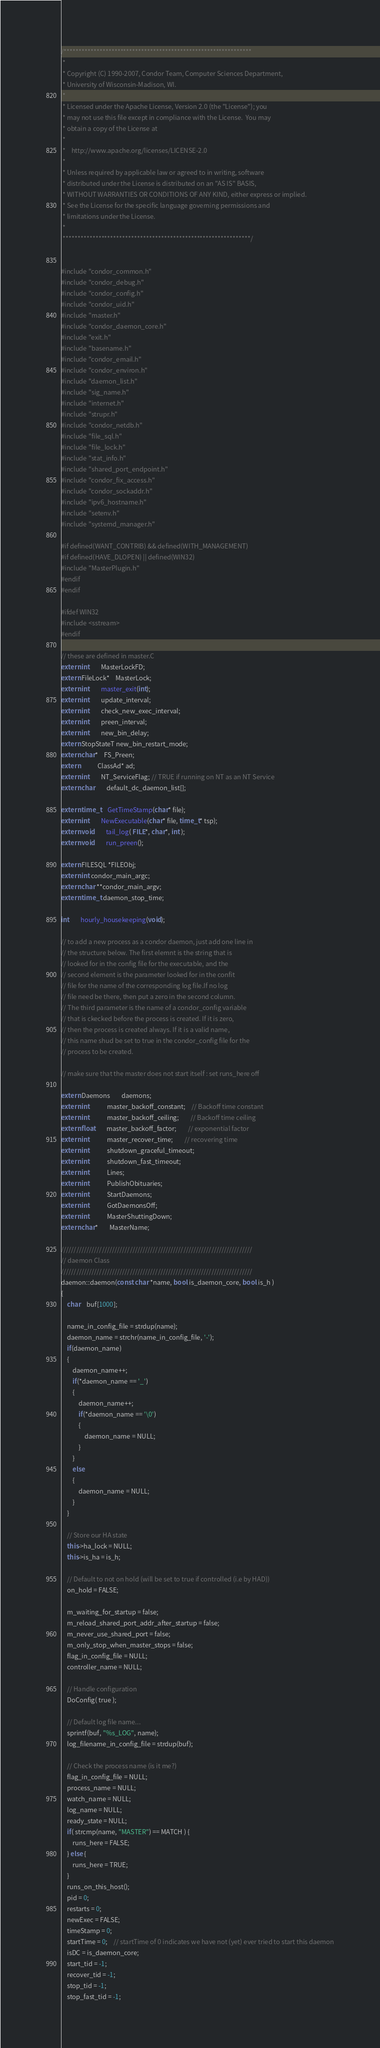<code> <loc_0><loc_0><loc_500><loc_500><_C++_>/***************************************************************
 *
 * Copyright (C) 1990-2007, Condor Team, Computer Sciences Department,
 * University of Wisconsin-Madison, WI.
 * 
 * Licensed under the Apache License, Version 2.0 (the "License"); you
 * may not use this file except in compliance with the License.  You may
 * obtain a copy of the License at
 * 
 *    http://www.apache.org/licenses/LICENSE-2.0
 * 
 * Unless required by applicable law or agreed to in writing, software
 * distributed under the License is distributed on an "AS IS" BASIS,
 * WITHOUT WARRANTIES OR CONDITIONS OF ANY KIND, either express or implied.
 * See the License for the specific language governing permissions and
 * limitations under the License.
 *
 ***************************************************************/


#include "condor_common.h"
#include "condor_debug.h"
#include "condor_config.h"
#include "condor_uid.h"
#include "master.h"
#include "condor_daemon_core.h"
#include "exit.h"
#include "basename.h"
#include "condor_email.h"
#include "condor_environ.h"
#include "daemon_list.h"
#include "sig_name.h"
#include "internet.h"
#include "strupr.h"
#include "condor_netdb.h"
#include "file_sql.h"
#include "file_lock.h"
#include "stat_info.h"
#include "shared_port_endpoint.h"
#include "condor_fix_access.h"
#include "condor_sockaddr.h"
#include "ipv6_hostname.h"
#include "setenv.h"
#include "systemd_manager.h"

#if defined(WANT_CONTRIB) && defined(WITH_MANAGEMENT)
#if defined(HAVE_DLOPEN) || defined(WIN32)
#include "MasterPlugin.h"
#endif
#endif

#ifdef WIN32
#include <sstream>
#endif

// these are defined in master.C
extern int 		MasterLockFD;
extern FileLock*	MasterLock;
extern int		master_exit(int);
extern int		update_interval;
extern int		check_new_exec_interval;
extern int		preen_interval;
extern int		new_bin_delay;
extern StopStateT new_bin_restart_mode;
extern char*	FS_Preen;
extern			ClassAd* ad;
extern int		NT_ServiceFlag; // TRUE if running on NT as an NT Service
extern char		default_dc_daemon_list[];

extern time_t	GetTimeStamp(char* file);
extern int 	   	NewExecutable(char* file, time_t* tsp);
extern void		tail_log( FILE*, char*, int );
extern void		run_preen();

extern FILESQL *FILEObj;
extern int condor_main_argc;
extern char **condor_main_argv;
extern time_t daemon_stop_time;

int		hourly_housekeeping(void);

// to add a new process as a condor daemon, just add one line in 
// the structure below. The first elemnt is the string that is 
// looked for in the config file for the executable, and the
// second element is the parameter looked for in the confit
// file for the name of the corresponding log file.If no log
// file need be there, then put a zero in the second column.
// The third parameter is the name of a condor_config variable
// that is ckecked before the process is created. If it is zero, 
// then the process is created always. If it is a valid name,
// this name shud be set to true in the condor_config file for the
// process to be created.

// make sure that the master does not start itself : set runs_here off

extern Daemons 		daemons;
extern int			master_backoff_constant;	// Backoff time constant
extern int			master_backoff_ceiling;		// Backoff time ceiling
extern float		master_backoff_factor;		// exponential factor
extern int			master_recover_time;		// recovering time
extern int			shutdown_graceful_timeout;
extern int			shutdown_fast_timeout;
extern int			Lines;
extern int			PublishObituaries;
extern int			StartDaemons;
extern int			GotDaemonsOff;
extern int			MasterShuttingDown;
extern char*		MasterName;

///////////////////////////////////////////////////////////////////////////
// daemon Class
///////////////////////////////////////////////////////////////////////////
daemon::daemon(const char *name, bool is_daemon_core, bool is_h )
{
	char	buf[1000];

	name_in_config_file = strdup(name);
	daemon_name = strchr(name_in_config_file, '-');
	if(daemon_name)
	{
		daemon_name++;
		if(*daemon_name == '_')
		{
			daemon_name++;
			if(*daemon_name == '\0')
			{
				daemon_name = NULL;
			}
		}
		else
		{
			daemon_name = NULL;
		}
	} 

	// Store our HA state
	this->ha_lock = NULL;
	this->is_ha = is_h;

	// Default to not on hold (will be set to true if controlled (i.e by HAD))
	on_hold = FALSE;

	m_waiting_for_startup = false;
	m_reload_shared_port_addr_after_startup = false;
	m_never_use_shared_port = false;
	m_only_stop_when_master_stops = false;
	flag_in_config_file = NULL;
	controller_name = NULL;

	// Handle configuration
	DoConfig( true );

	// Default log file name...
	sprintf(buf, "%s_LOG", name);
	log_filename_in_config_file = strdup(buf);

	// Check the process name (is it me?)
	flag_in_config_file = NULL;
	process_name = NULL;
	watch_name = NULL;
	log_name = NULL;
	ready_state = NULL;
	if( strcmp(name, "MASTER") == MATCH ) {
		runs_here = FALSE;
	} else {
		runs_here = TRUE;
	}
	runs_on_this_host();
	pid = 0;
	restarts = 0;
	newExec = FALSE; 
	timeStamp = 0;
	startTime = 0;	// startTime of 0 indicates we have not (yet) ever tried to start this daemon
	isDC = is_daemon_core;
	start_tid = -1;
	recover_tid = -1;
	stop_tid = -1;
	stop_fast_tid = -1;</code> 